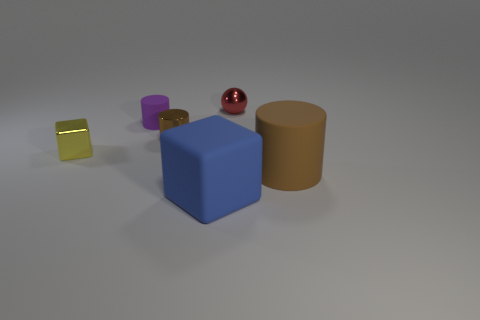Subtract all tiny cylinders. How many cylinders are left? 1 Add 1 purple rubber objects. How many objects exist? 7 Subtract all yellow cubes. How many cubes are left? 1 Subtract all cubes. How many objects are left? 4 Subtract all cyan spheres. Subtract all red cubes. How many spheres are left? 1 Subtract all red cylinders. How many brown spheres are left? 0 Subtract all small yellow objects. Subtract all metal objects. How many objects are left? 2 Add 5 tiny spheres. How many tiny spheres are left? 6 Add 5 small rubber things. How many small rubber things exist? 6 Subtract 0 cyan balls. How many objects are left? 6 